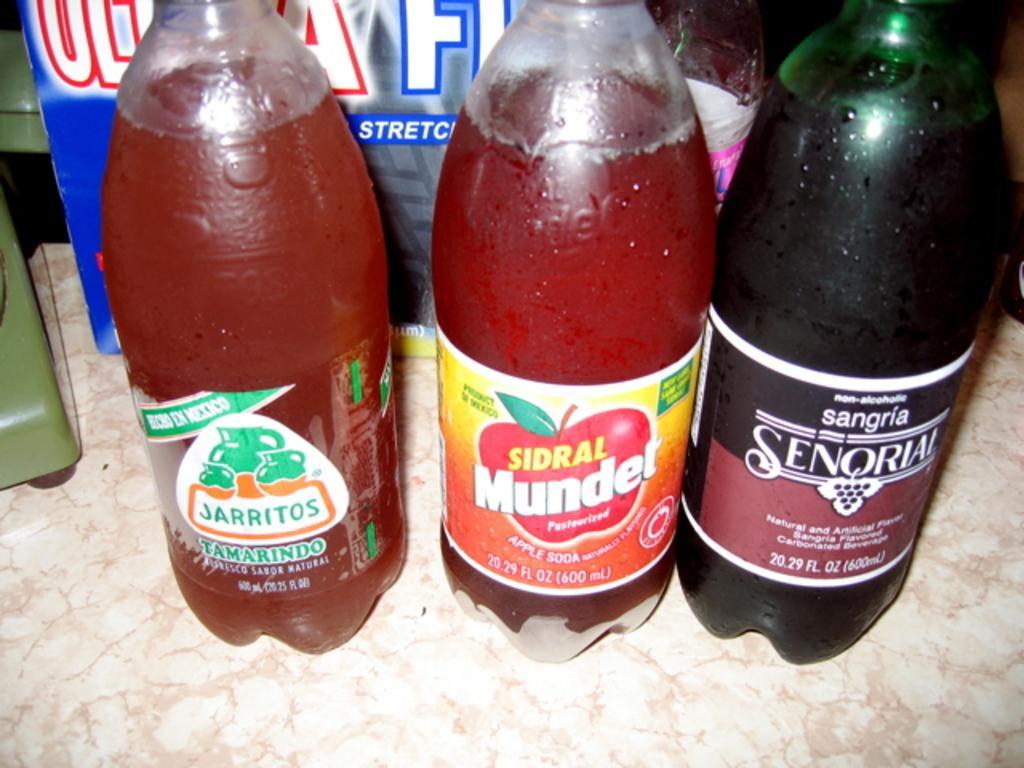Describe this image in one or two sentences. In the image there is a table. On table we can see three bottles on which it is labelled as tamarindo. In background there is a pink color bag. 